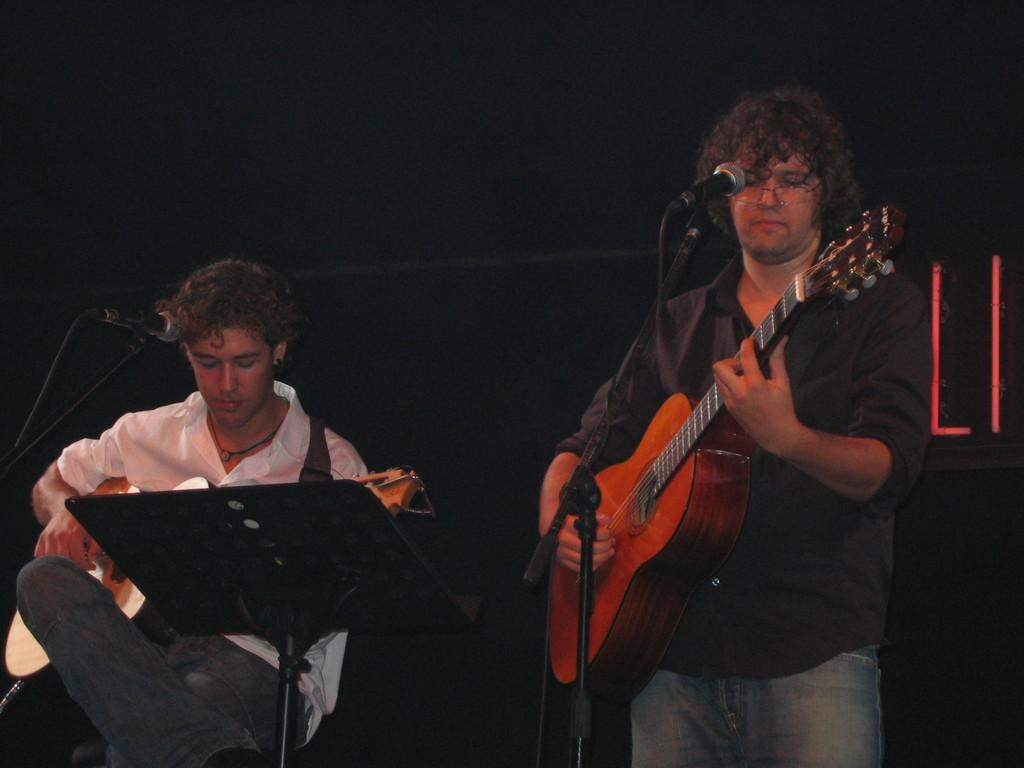What is the man in the image doing? There is a man standing in the image, and he is playing a guitar. Are there any other people in the image? Yes, there is a man seated in the image, and he is also playing a guitar. What object is present between the two men? There is a microphone in front of the two men. How does the heat affect the performance of the two men in the image? There is no information about heat or temperature in the image, so we cannot determine its effect on the performance of the two men. 